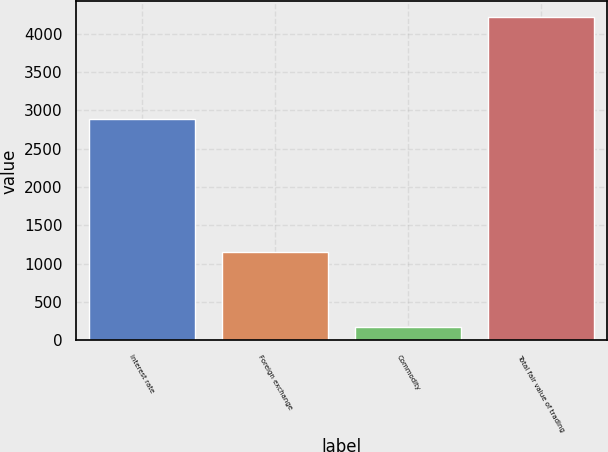Convert chart. <chart><loc_0><loc_0><loc_500><loc_500><bar_chart><fcel>Interest rate<fcel>Foreign exchange<fcel>Commodity<fcel>Total fair value of trading<nl><fcel>2884<fcel>1148<fcel>179<fcel>4211<nl></chart> 